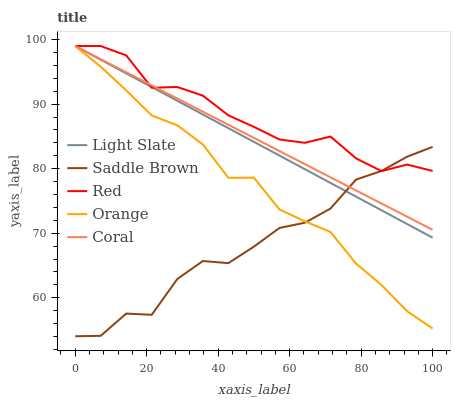Does Saddle Brown have the minimum area under the curve?
Answer yes or no. Yes. Does Red have the maximum area under the curve?
Answer yes or no. Yes. Does Orange have the minimum area under the curve?
Answer yes or no. No. Does Orange have the maximum area under the curve?
Answer yes or no. No. Is Light Slate the smoothest?
Answer yes or no. Yes. Is Saddle Brown the roughest?
Answer yes or no. Yes. Is Orange the smoothest?
Answer yes or no. No. Is Orange the roughest?
Answer yes or no. No. Does Saddle Brown have the lowest value?
Answer yes or no. Yes. Does Orange have the lowest value?
Answer yes or no. No. Does Red have the highest value?
Answer yes or no. Yes. Does Saddle Brown have the highest value?
Answer yes or no. No. Does Saddle Brown intersect Light Slate?
Answer yes or no. Yes. Is Saddle Brown less than Light Slate?
Answer yes or no. No. Is Saddle Brown greater than Light Slate?
Answer yes or no. No. 